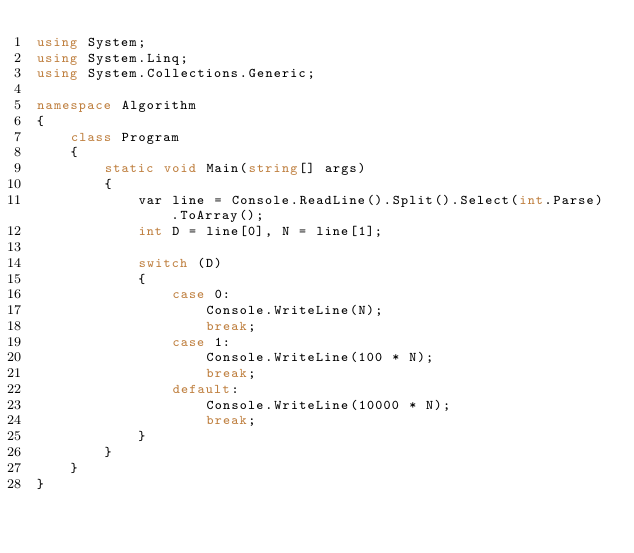Convert code to text. <code><loc_0><loc_0><loc_500><loc_500><_C#_>using System;
using System.Linq;
using System.Collections.Generic;

namespace Algorithm
{
    class Program
    {
        static void Main(string[] args)
        {
            var line = Console.ReadLine().Split().Select(int.Parse).ToArray();
            int D = line[0], N = line[1];

            switch (D)
            {
                case 0:
                    Console.WriteLine(N);
                    break;
                case 1:
                    Console.WriteLine(100 * N);
                    break;
                default:
                    Console.WriteLine(10000 * N);
                    break;
            }
        }
    }
}</code> 